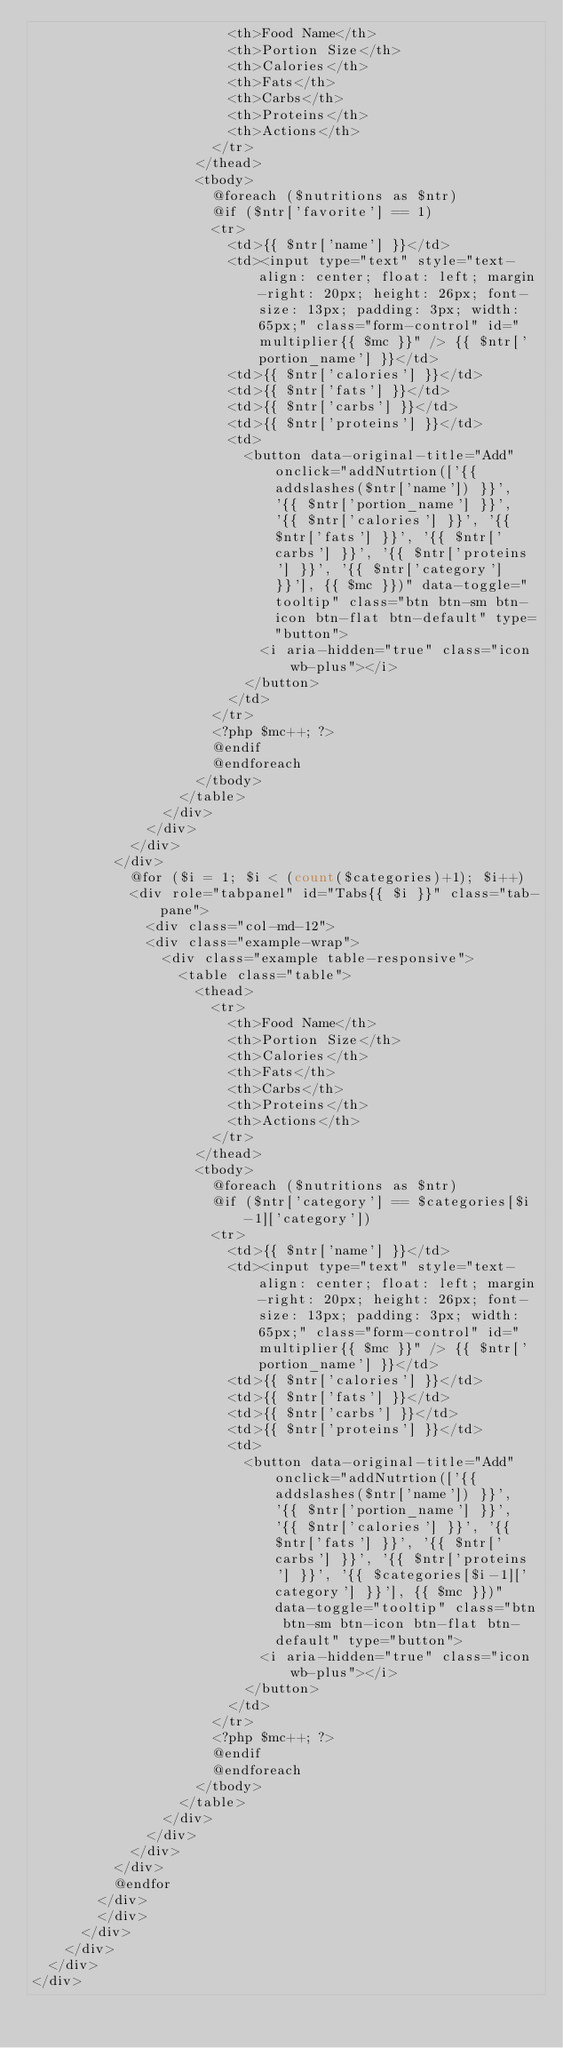Convert code to text. <code><loc_0><loc_0><loc_500><loc_500><_PHP_>												<th>Food Name</th>
												<th>Portion Size</th>
												<th>Calories</th>
												<th>Fats</th>
												<th>Carbs</th>
												<th>Proteins</th>
												<th>Actions</th>
											</tr>
										</thead>
										<tbody>
											@foreach ($nutritions as $ntr)
											@if ($ntr['favorite'] == 1)
											<tr>
												<td>{{ $ntr['name'] }}</td>
												<td><input type="text" style="text-align: center; float: left; margin-right: 20px; height: 26px; font-size: 13px; padding: 3px; width: 65px;" class="form-control" id="multiplier{{ $mc }}" /> {{ $ntr['portion_name'] }}</td>
												<td>{{ $ntr['calories'] }}</td>
												<td>{{ $ntr['fats'] }}</td>
												<td>{{ $ntr['carbs'] }}</td>
												<td>{{ $ntr['proteins'] }}</td>
												<td>
													<button data-original-title="Add" onclick="addNutrtion(['{{ addslashes($ntr['name']) }}', '{{ $ntr['portion_name'] }}', '{{ $ntr['calories'] }}', '{{ $ntr['fats'] }}', '{{ $ntr['carbs'] }}', '{{ $ntr['proteins'] }}', '{{ $ntr['category'] }}'], {{ $mc }})" data-toggle="tooltip" class="btn btn-sm btn-icon btn-flat btn-default" type="button">
														<i aria-hidden="true" class="icon wb-plus"></i>
													</button>
												</td>
											</tr>
											<?php $mc++; ?>
											@endif
											@endforeach
										</tbody>
									</table>
								</div>
							</div>
						</div>
					</div>
						@for ($i = 1; $i < (count($categories)+1); $i++)
						<div role="tabpanel" id="Tabs{{ $i }}" class="tab-pane">
							<div class="col-md-12">
							<div class="example-wrap">
								<div class="example table-responsive">
									<table class="table">
										<thead>
											<tr>
												<th>Food Name</th>
												<th>Portion Size</th>
												<th>Calories</th>
												<th>Fats</th>
												<th>Carbs</th>
												<th>Proteins</th>
												<th>Actions</th>
											</tr>
										</thead>
										<tbody>
											@foreach ($nutritions as $ntr)
											@if ($ntr['category'] == $categories[$i-1]['category'])
											<tr>
												<td>{{ $ntr['name'] }}</td>
												<td><input type="text" style="text-align: center; float: left; margin-right: 20px; height: 26px; font-size: 13px; padding: 3px; width: 65px;" class="form-control" id="multiplier{{ $mc }}" /> {{ $ntr['portion_name'] }}</td>
												<td>{{ $ntr['calories'] }}</td>
												<td>{{ $ntr['fats'] }}</td>
												<td>{{ $ntr['carbs'] }}</td>
												<td>{{ $ntr['proteins'] }}</td>
												<td>
													<button data-original-title="Add" onclick="addNutrtion(['{{ addslashes($ntr['name']) }}', '{{ $ntr['portion_name'] }}', '{{ $ntr['calories'] }}', '{{ $ntr['fats'] }}', '{{ $ntr['carbs'] }}', '{{ $ntr['proteins'] }}', '{{ $categories[$i-1]['category'] }}'], {{ $mc }})" data-toggle="tooltip" class="btn btn-sm btn-icon btn-flat btn-default" type="button">
														<i aria-hidden="true" class="icon wb-plus"></i>
													</button>
												</td>
											</tr>
											<?php $mc++; ?>
											@endif
											@endforeach
										</tbody>
									</table>
								</div>
							</div>
						</div>
					</div>
					@endfor
				</div>
				</div>
			</div>
		</div>
	</div>
</div>
</code> 